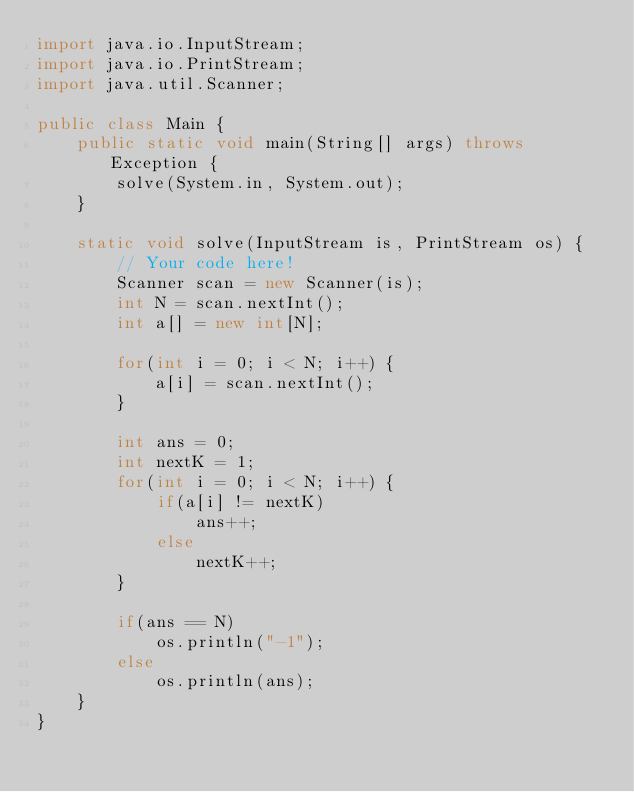Convert code to text. <code><loc_0><loc_0><loc_500><loc_500><_Java_>import java.io.InputStream;
import java.io.PrintStream;
import java.util.Scanner;

public class Main {
    public static void main(String[] args) throws Exception {
        solve(System.in, System.out);
    }

    static void solve(InputStream is, PrintStream os) {
        // Your code here!
        Scanner scan = new Scanner(is);
        int N = scan.nextInt();
        int a[] = new int[N];

        for(int i = 0; i < N; i++) {
            a[i] = scan.nextInt();
        }

        int ans = 0;
        int nextK = 1;
        for(int i = 0; i < N; i++) {
            if(a[i] != nextK)
                ans++;
            else
                nextK++;
        }

        if(ans == N)
            os.println("-1");
        else
            os.println(ans);
    }
}</code> 